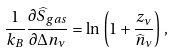<formula> <loc_0><loc_0><loc_500><loc_500>\frac { 1 } { k _ { B } } \frac { \partial \widehat { S } _ { g a s } } { \partial \Delta n _ { \nu } } = \ln \, \left ( 1 + \frac { z _ { \nu } } { \widehat { n } _ { \nu } } \right ) \, ,</formula> 